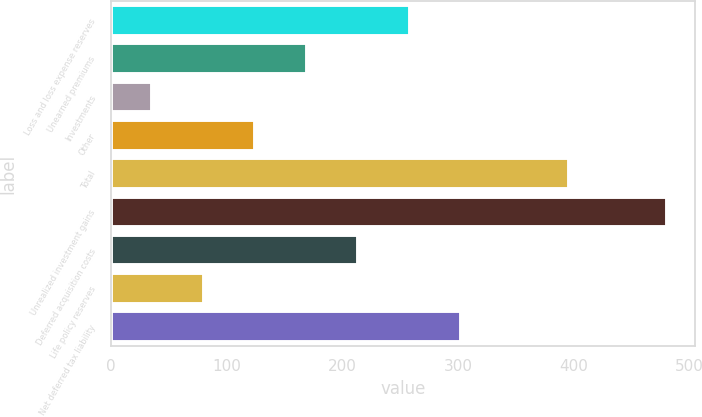Convert chart to OTSL. <chart><loc_0><loc_0><loc_500><loc_500><bar_chart><fcel>Loss and loss expense reserves<fcel>Unearned premiums<fcel>Investments<fcel>Other<fcel>Total<fcel>Unrealized investment gains<fcel>Deferred acquisition costs<fcel>Life policy reserves<fcel>Net deferred tax liability<nl><fcel>258.5<fcel>169.5<fcel>36<fcel>125<fcel>396<fcel>481<fcel>214<fcel>80.5<fcel>303<nl></chart> 